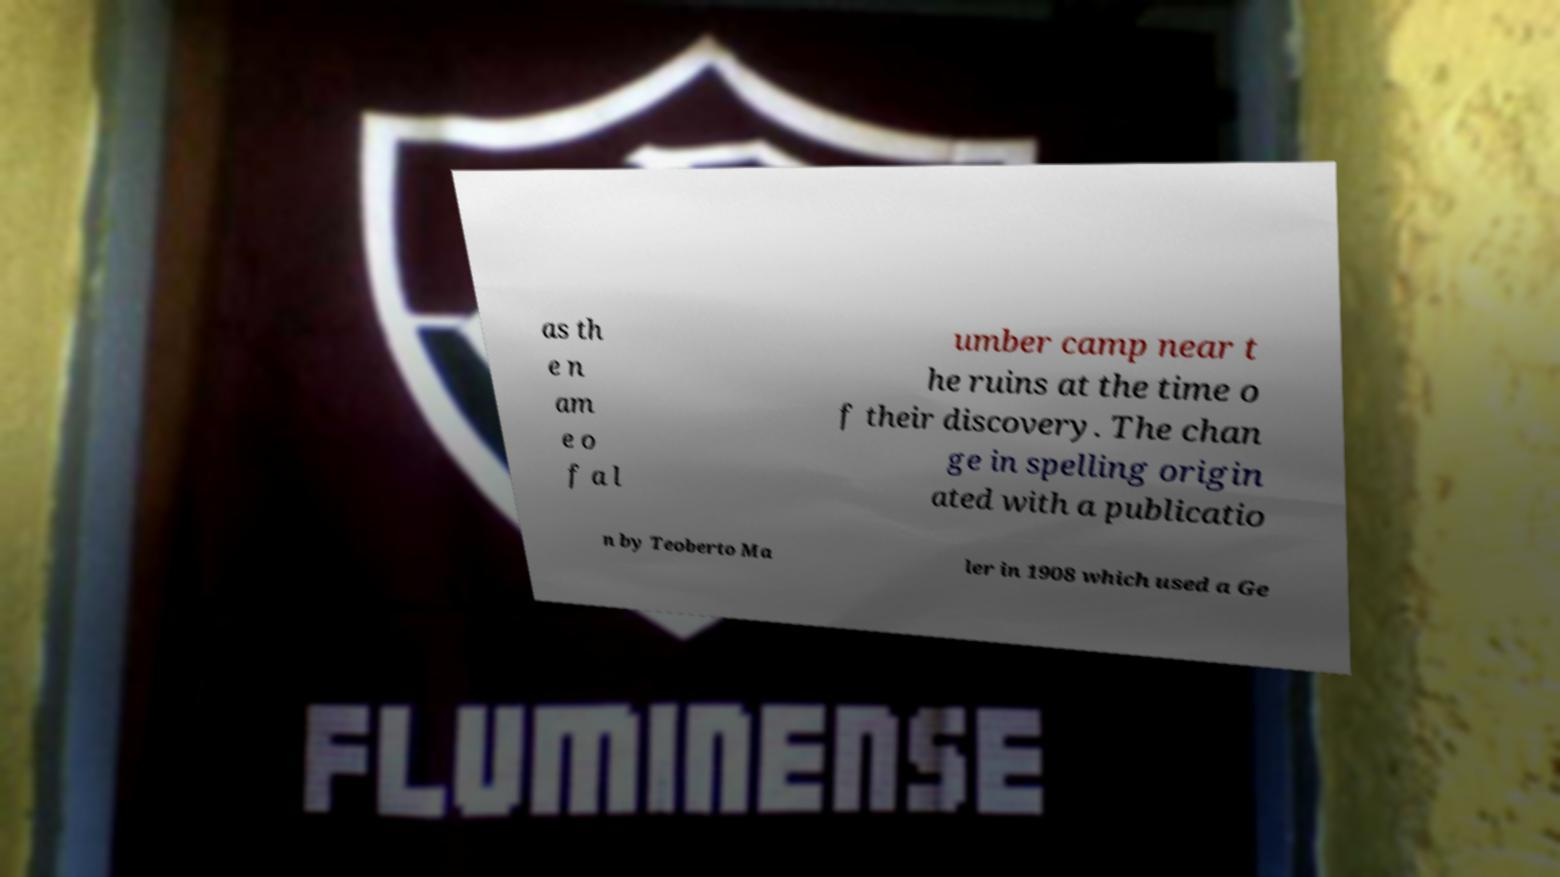For documentation purposes, I need the text within this image transcribed. Could you provide that? as th e n am e o f a l umber camp near t he ruins at the time o f their discovery. The chan ge in spelling origin ated with a publicatio n by Teoberto Ma ler in 1908 which used a Ge 